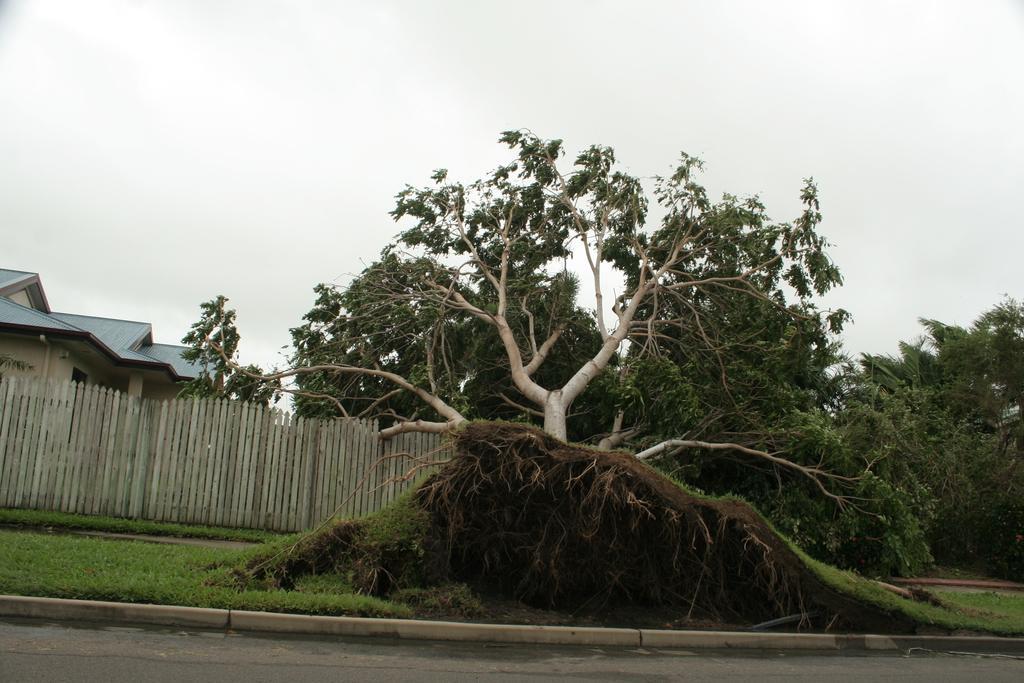How would you summarize this image in a sentence or two? In this picture we can see many trees. On the left there is a building near to wooden fencing. At the bottom we can see green grass near to the road. At the top we can see sky and clouds. 